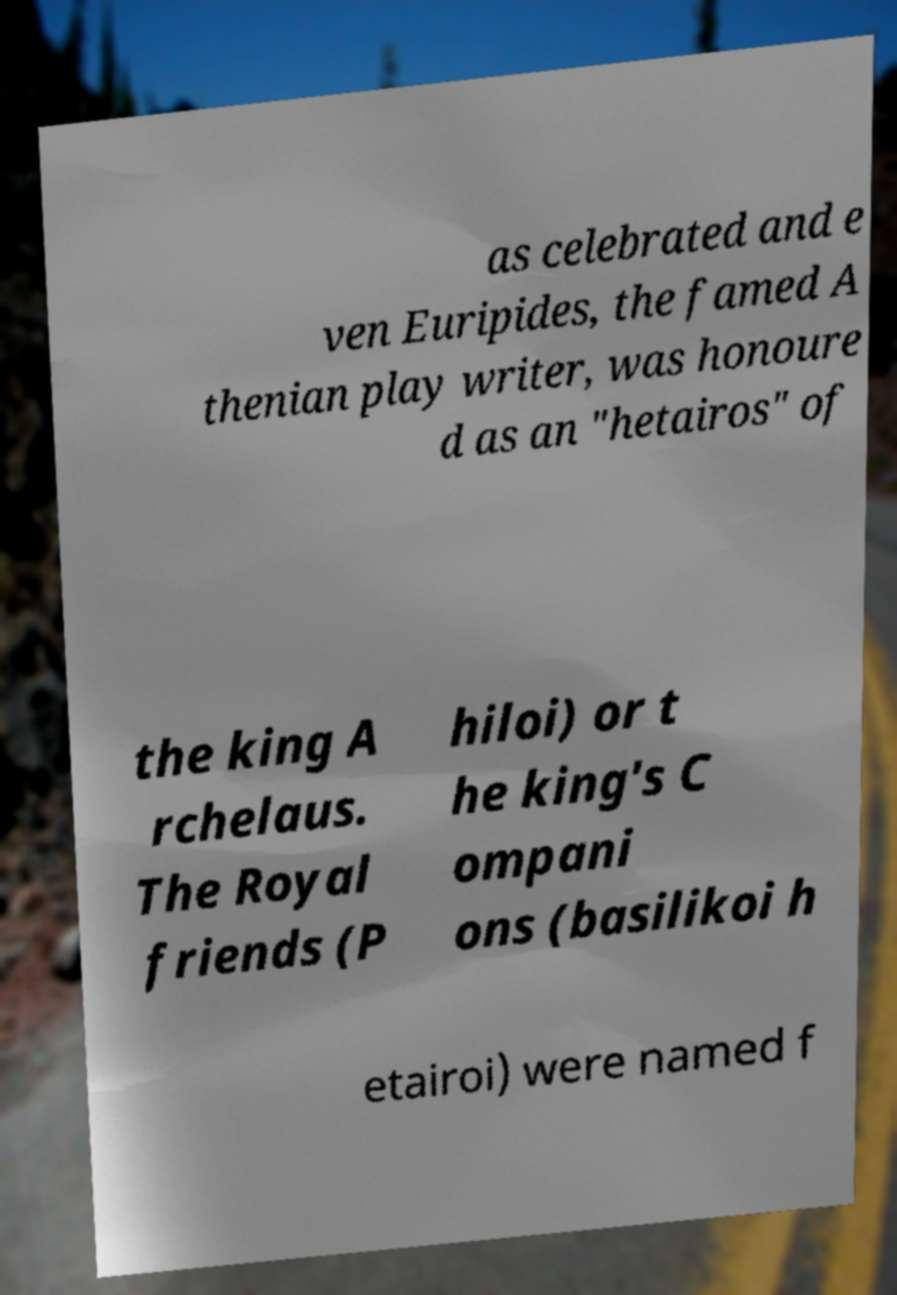What messages or text are displayed in this image? I need them in a readable, typed format. as celebrated and e ven Euripides, the famed A thenian play writer, was honoure d as an "hetairos" of the king A rchelaus. The Royal friends (P hiloi) or t he king's C ompani ons (basilikoi h etairoi) were named f 